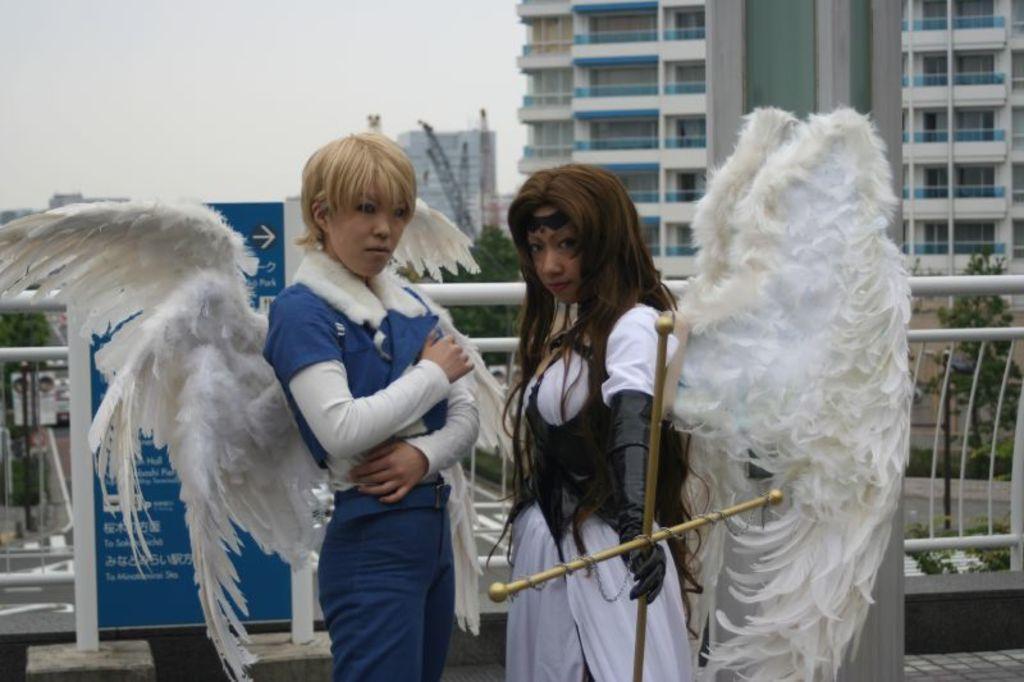Could you give a brief overview of what you see in this image? Here we can see two people. These two people have wings. This person is holding an object. Background there are trees, hoarding and buildings. 